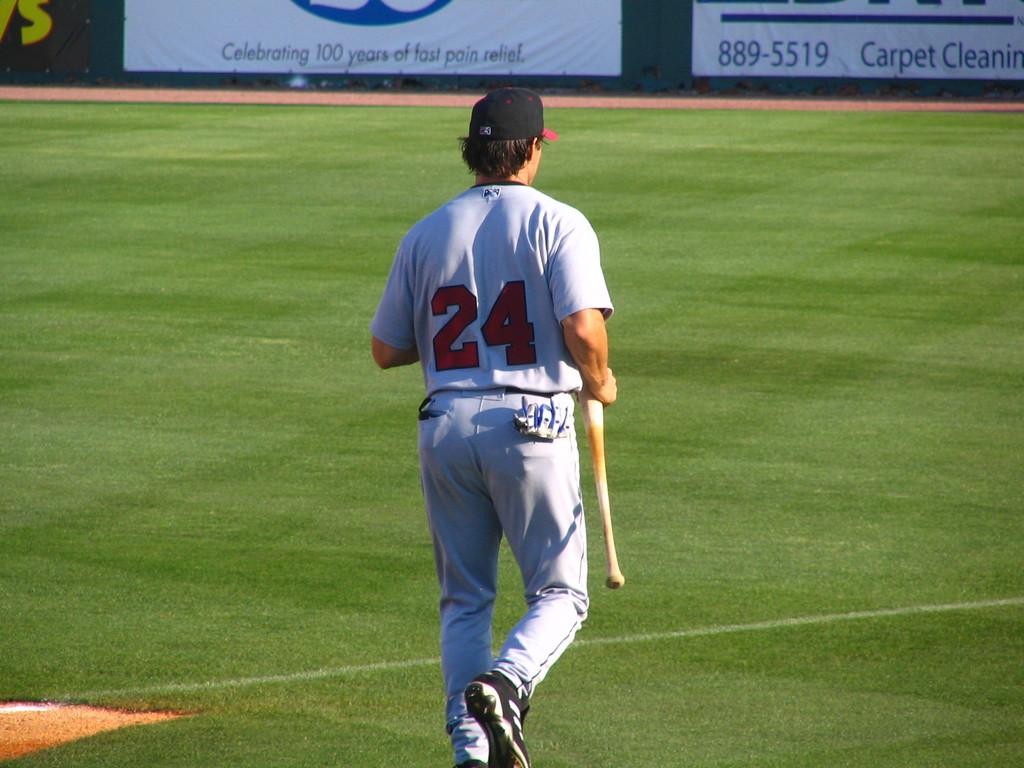What is the number on the shirt?
Make the answer very short. 24. What service is advertised on the wall?
Provide a short and direct response. Carpet cleaning. 